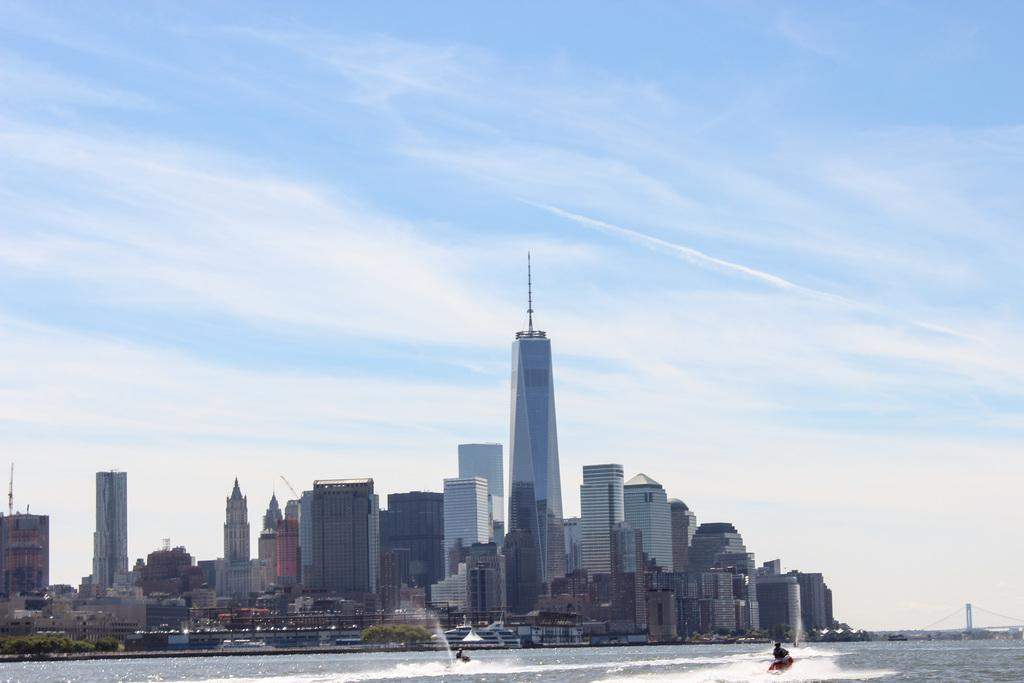What are the people in the foreground doing in the image? The people in the foreground are surfing using motor boards. What can be seen in the background of the image? In the background, there are towers, buildings, trees, a road, and a bridge. What is the condition of the sky in the image? The sky is cloudy in the image. Can you see a veil being used by someone in the image? There is no veil present in the image. What type of credit card is being used by the people surfing in the image? There is no credit card visible in the image; the people are using motor boards for surfing. 